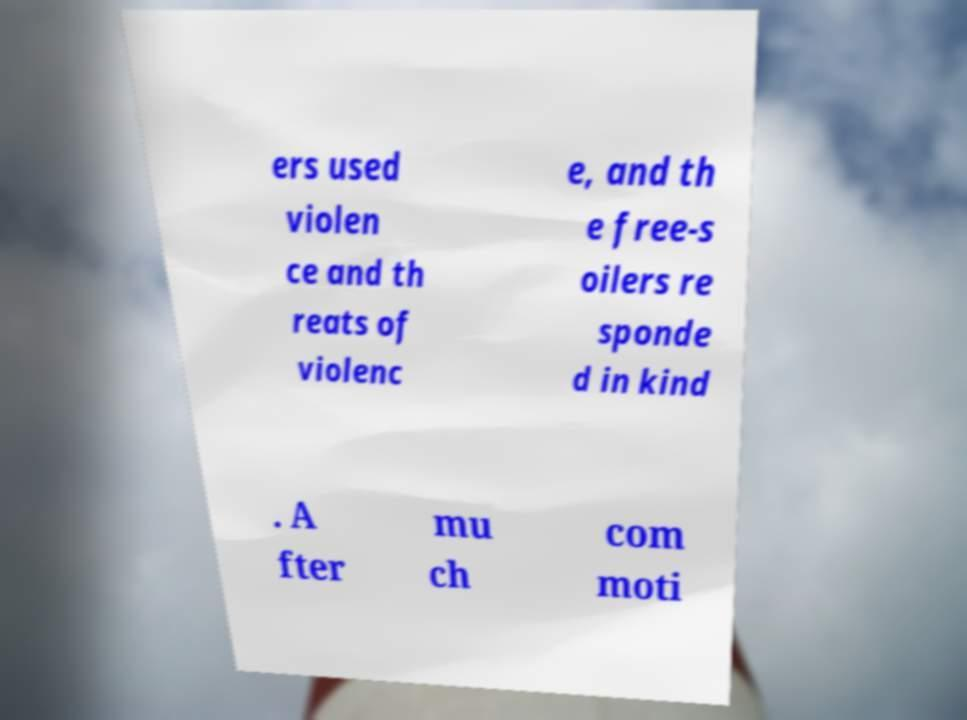Please read and relay the text visible in this image. What does it say? ers used violen ce and th reats of violenc e, and th e free-s oilers re sponde d in kind . A fter mu ch com moti 